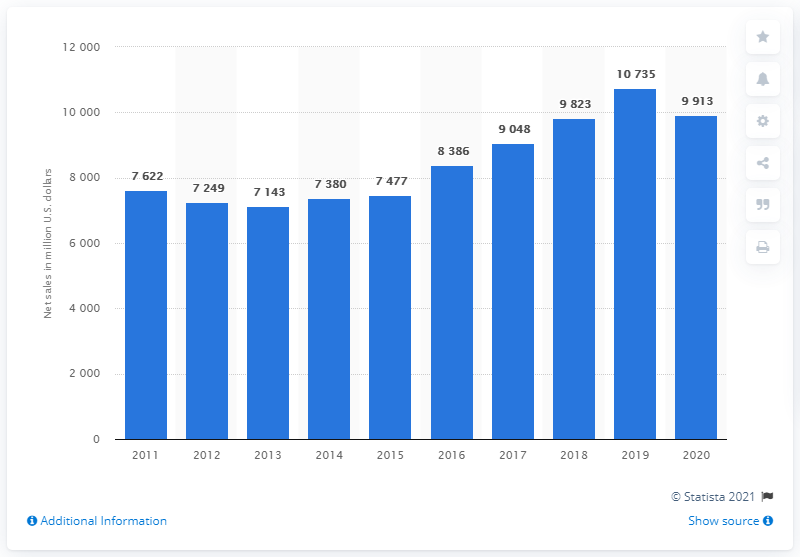Outline some significant characteristics in this image. In 2020, the net sales of Boston Scientific were approximately 9,913 dollars. 